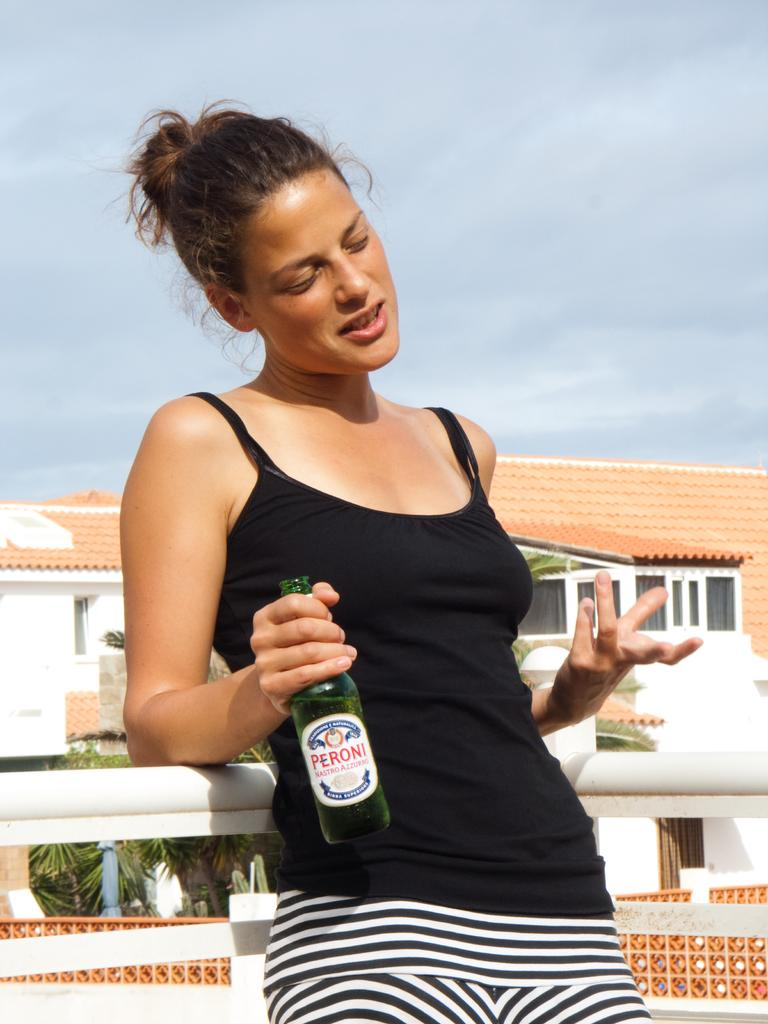Who is present in the image? There is a woman in the image. What is the woman holding in the image? The woman is holding a bottle with a drink in it. What is the woman's facial expression in the image? The woman is smiling. What can be seen in the background of the image? There is a house, trees, a fence, and the sky visible in the background of the image. What is the condition of the sky in the image? The sky is visible with clouds in the background of the image. What type of card is the woman using to create friction in the image? There is no card or friction present in the image. 